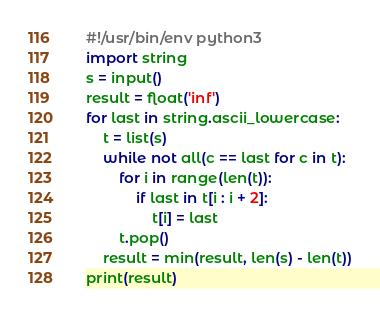Convert code to text. <code><loc_0><loc_0><loc_500><loc_500><_Python_>#!/usr/bin/env python3
import string
s = input()
result = float('inf')
for last in string.ascii_lowercase:
    t = list(s)
    while not all(c == last for c in t):
        for i in range(len(t)):
            if last in t[i : i + 2]:
                t[i] = last
        t.pop()
    result = min(result, len(s) - len(t))
print(result)
</code> 